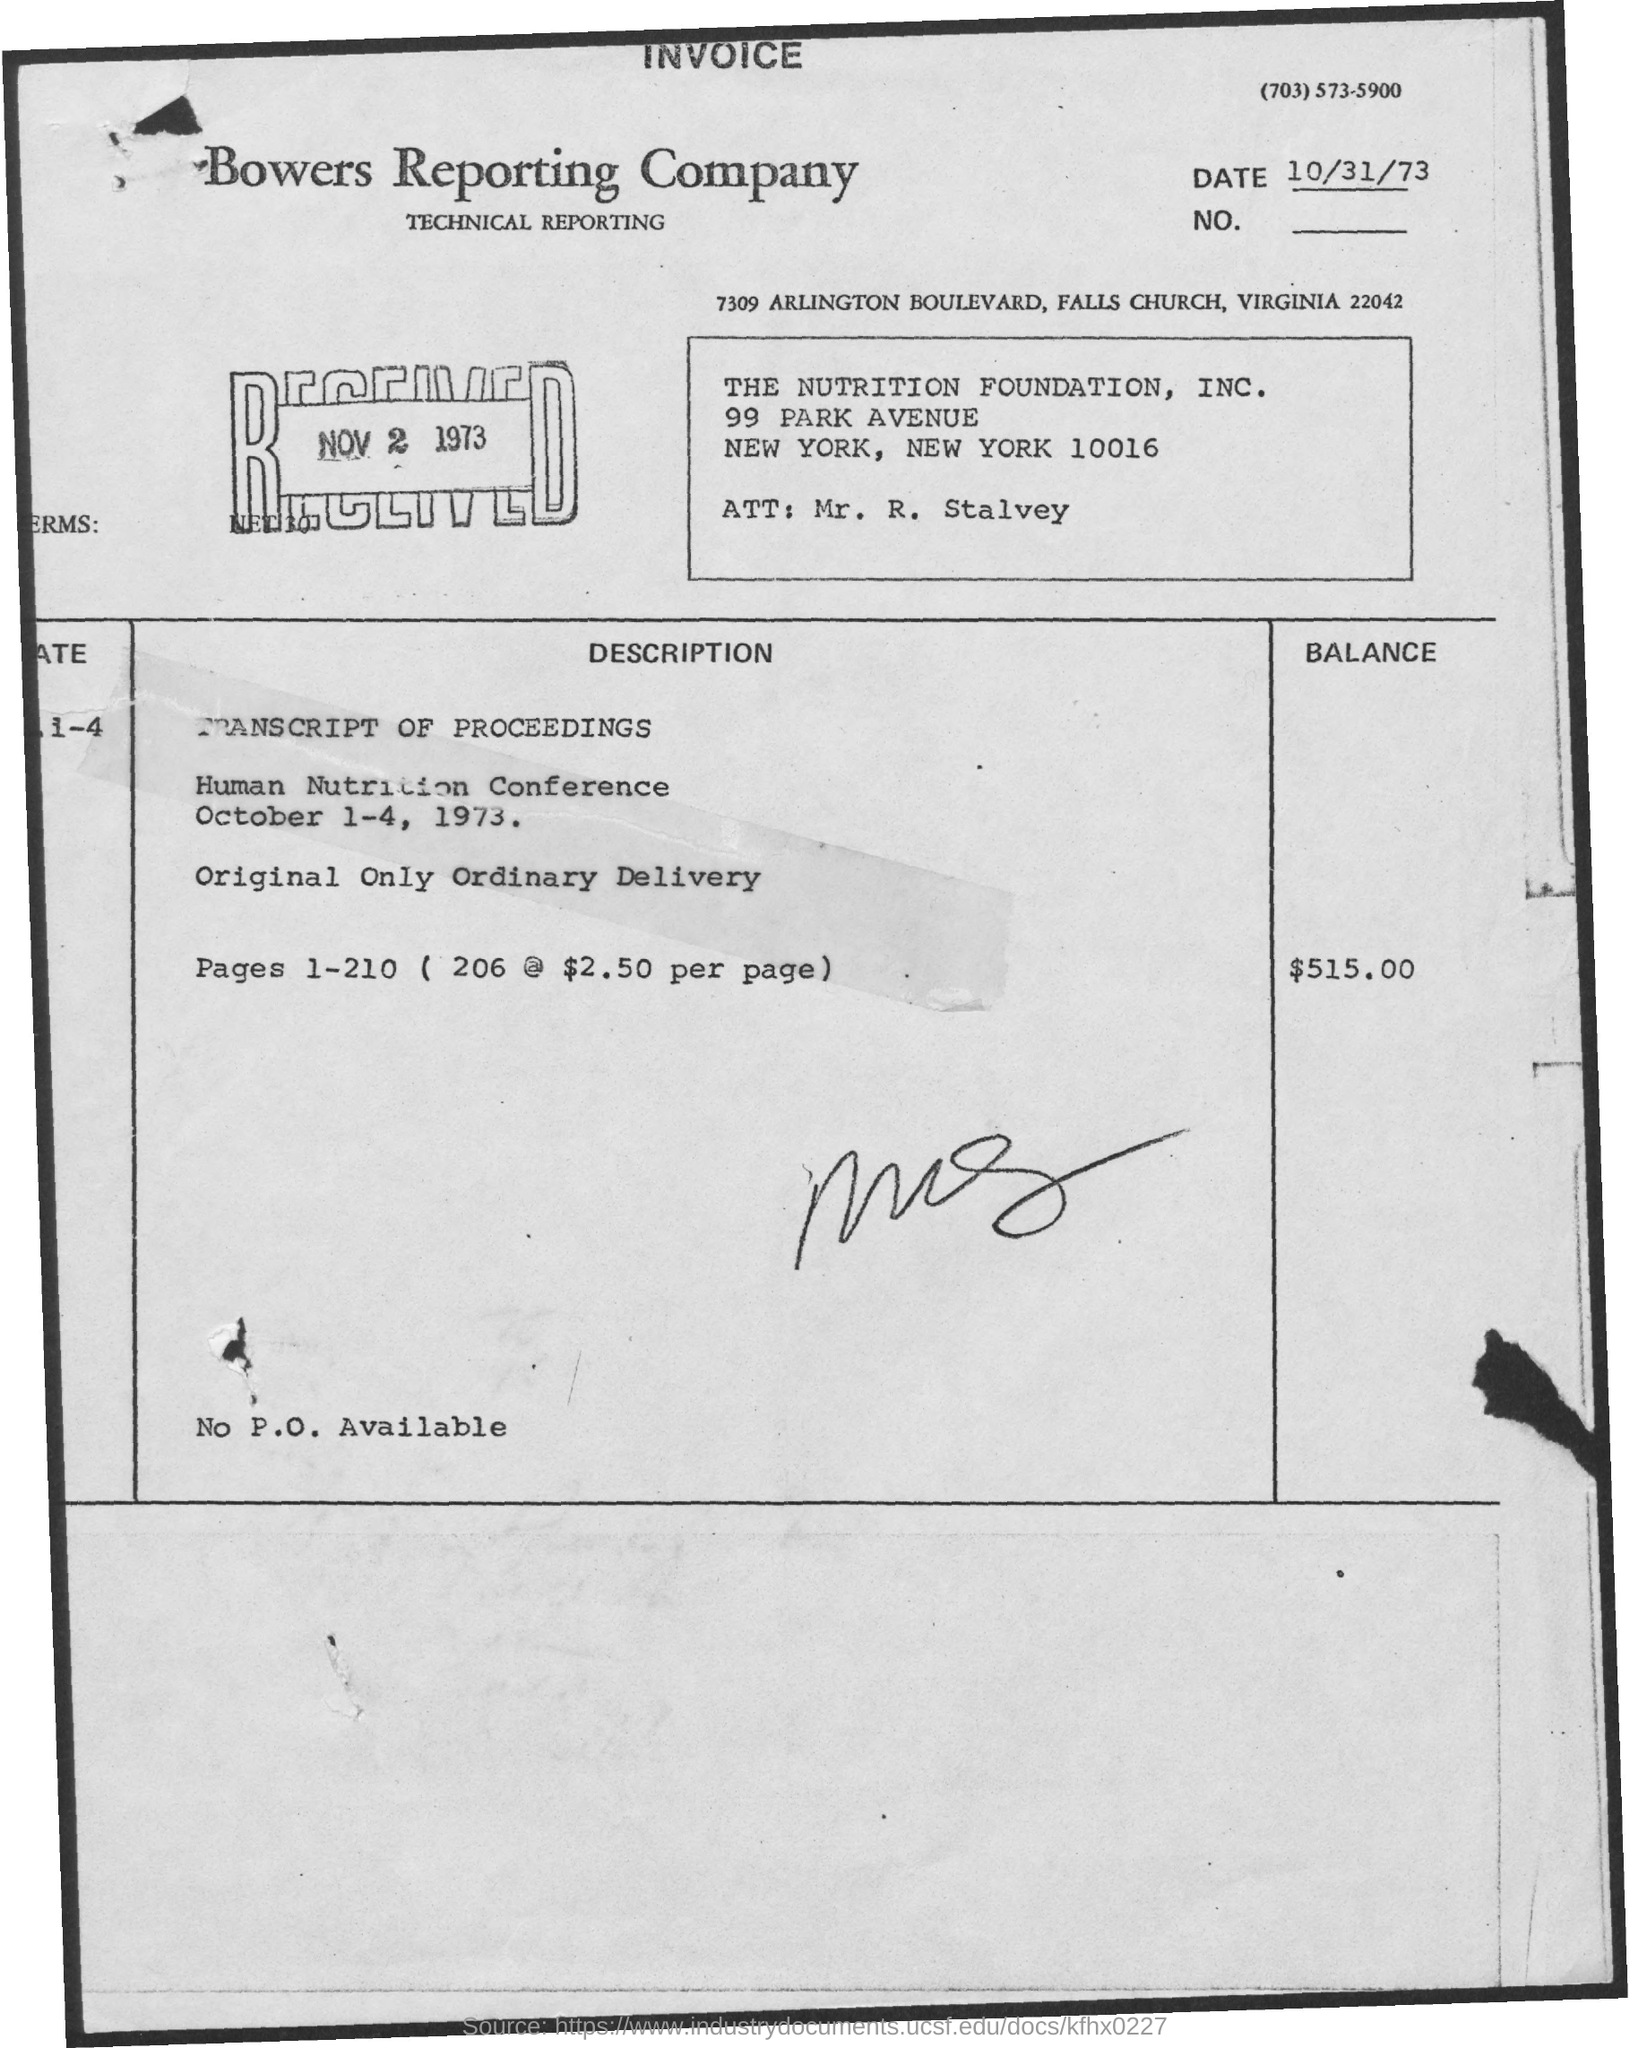What is the balance amount?
Offer a very short reply. $515.00. What is received date?
Your answer should be compact. Nov 2 1973. 